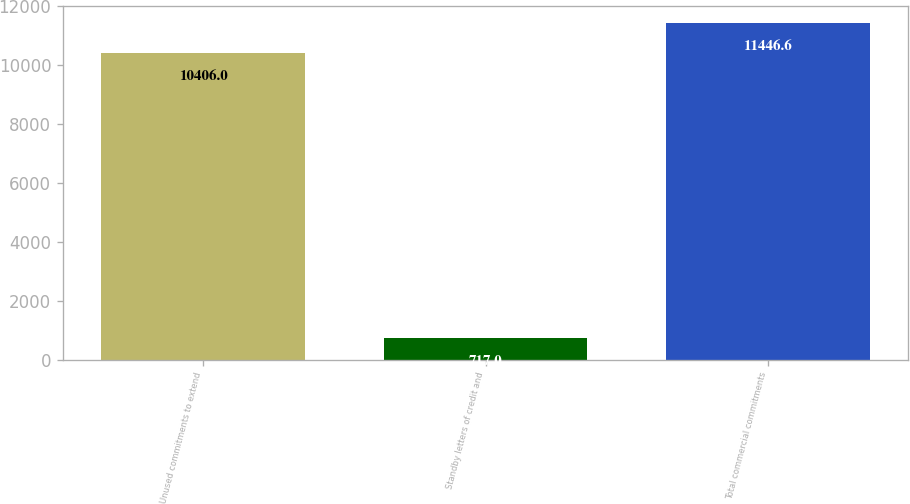<chart> <loc_0><loc_0><loc_500><loc_500><bar_chart><fcel>Unused commitments to extend<fcel>Standby letters of credit and<fcel>Total commercial commitments<nl><fcel>10406<fcel>717<fcel>11446.6<nl></chart> 